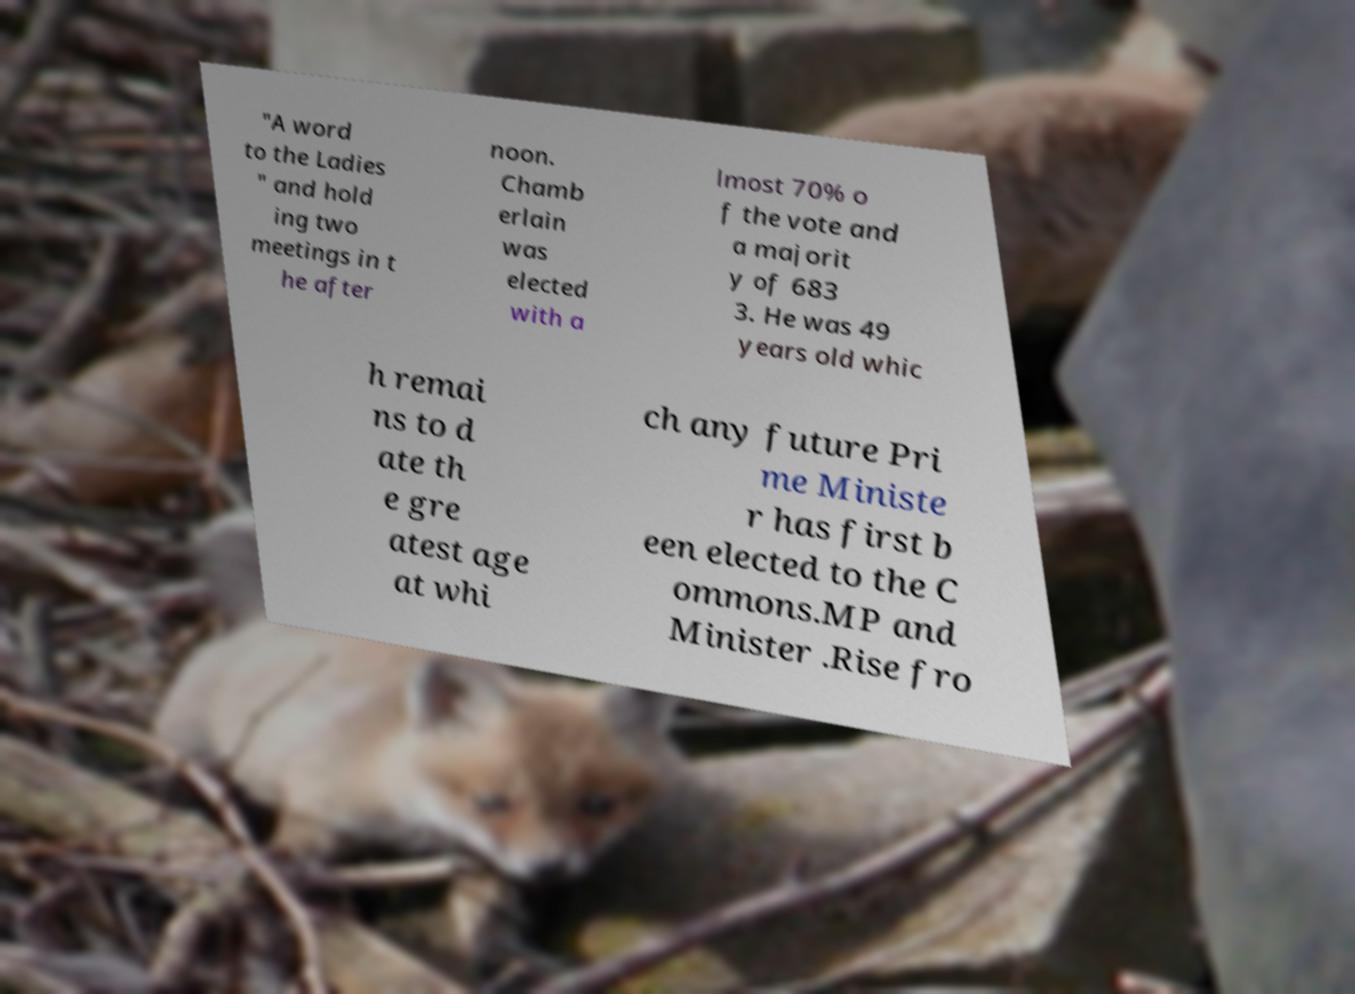Could you assist in decoding the text presented in this image and type it out clearly? "A word to the Ladies " and hold ing two meetings in t he after noon. Chamb erlain was elected with a lmost 70% o f the vote and a majorit y of 683 3. He was 49 years old whic h remai ns to d ate th e gre atest age at whi ch any future Pri me Ministe r has first b een elected to the C ommons.MP and Minister .Rise fro 